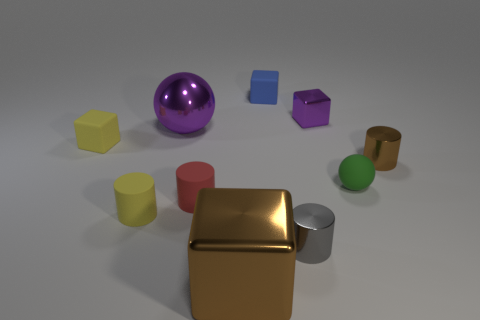What is the color of the large sphere?
Give a very brief answer. Purple. How many large objects are purple metal balls or gray metallic cylinders?
Ensure brevity in your answer.  1. What material is the block that is the same color as the shiny ball?
Keep it short and to the point. Metal. Is the material of the big purple sphere that is to the left of the small blue object the same as the brown thing right of the large brown shiny object?
Your response must be concise. Yes. Are any small green spheres visible?
Give a very brief answer. Yes. Is the number of tiny cylinders behind the red thing greater than the number of brown shiny cylinders that are to the left of the purple block?
Your answer should be compact. Yes. There is a purple thing that is the same shape as the tiny green rubber object; what material is it?
Provide a succinct answer. Metal. There is a small matte block on the left side of the blue block; is its color the same as the matte object in front of the small red rubber object?
Give a very brief answer. Yes. The tiny green rubber thing is what shape?
Keep it short and to the point. Sphere. Is the number of purple spheres that are behind the brown cube greater than the number of big blue shiny things?
Ensure brevity in your answer.  Yes. 